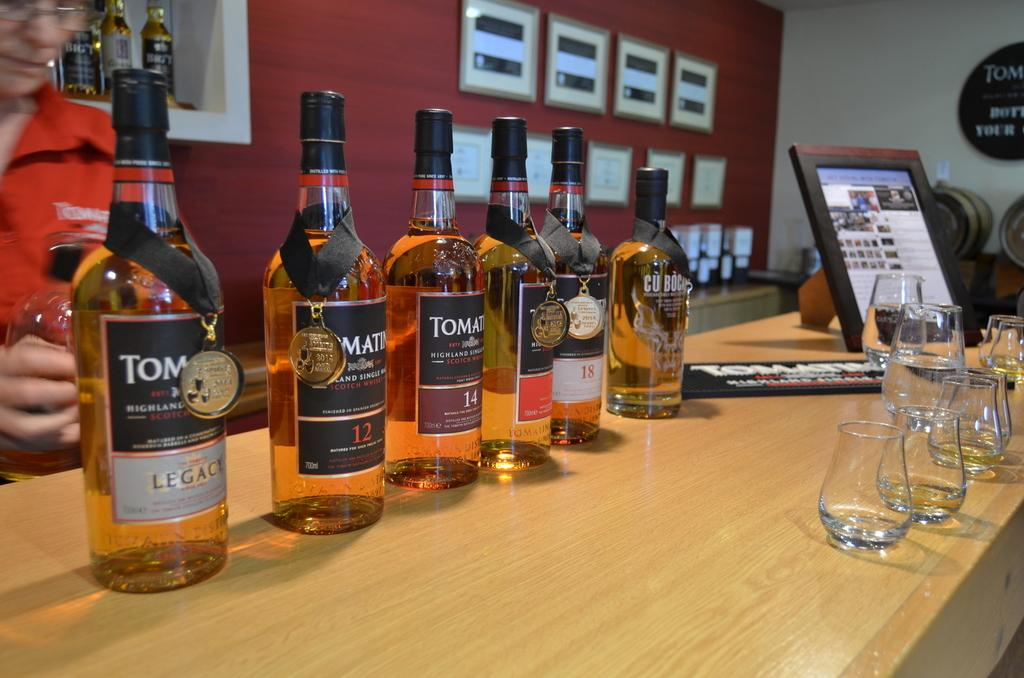Provide a one-sentence caption for the provided image. Lined up on a table are several bottles, including Legacy, 12, 14, and 18. 